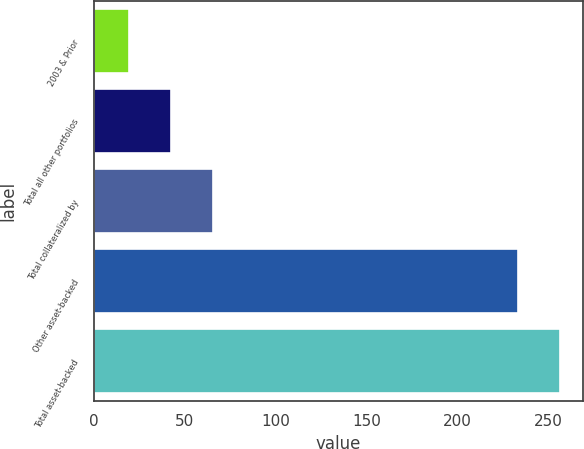Convert chart. <chart><loc_0><loc_0><loc_500><loc_500><bar_chart><fcel>2003 & Prior<fcel>Total all other portfolios<fcel>Total collateralized by<fcel>Other asset-backed<fcel>Total asset-backed<nl><fcel>19<fcel>42.3<fcel>65.6<fcel>233<fcel>256.3<nl></chart> 